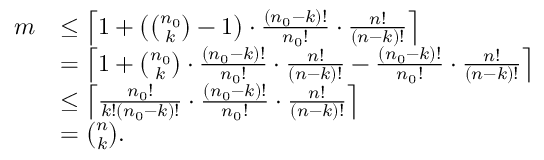<formula> <loc_0><loc_0><loc_500><loc_500>\begin{array} { r l } { m } & { \leq \left \lceil 1 + \left ( \binom { n _ { 0 } } { k } - 1 \right ) \cdot \frac { ( n _ { 0 } - k ) ! } { n _ { 0 } ! } \cdot \frac { n ! } { ( n - k ) ! } \right \rceil } \\ & { = \left \lceil 1 + \binom { n _ { 0 } } { k } \cdot \frac { ( n _ { 0 } - k ) ! } { n _ { 0 } ! } \cdot \frac { n ! } { ( n - k ) ! } - \frac { ( n _ { 0 } - k ) ! } { n _ { 0 } ! } \cdot \frac { n ! } { ( n - k ) ! } \right \rceil } \\ & { \leq \left \lceil \frac { n _ { 0 } ! } { k ! ( n _ { 0 } - k ) ! } \cdot \frac { ( n _ { 0 } - k ) ! } { n _ { 0 } ! } \cdot \frac { n ! } { ( n - k ) ! } \right \rceil } \\ & { = \binom { n } { k } . } \end{array}</formula> 